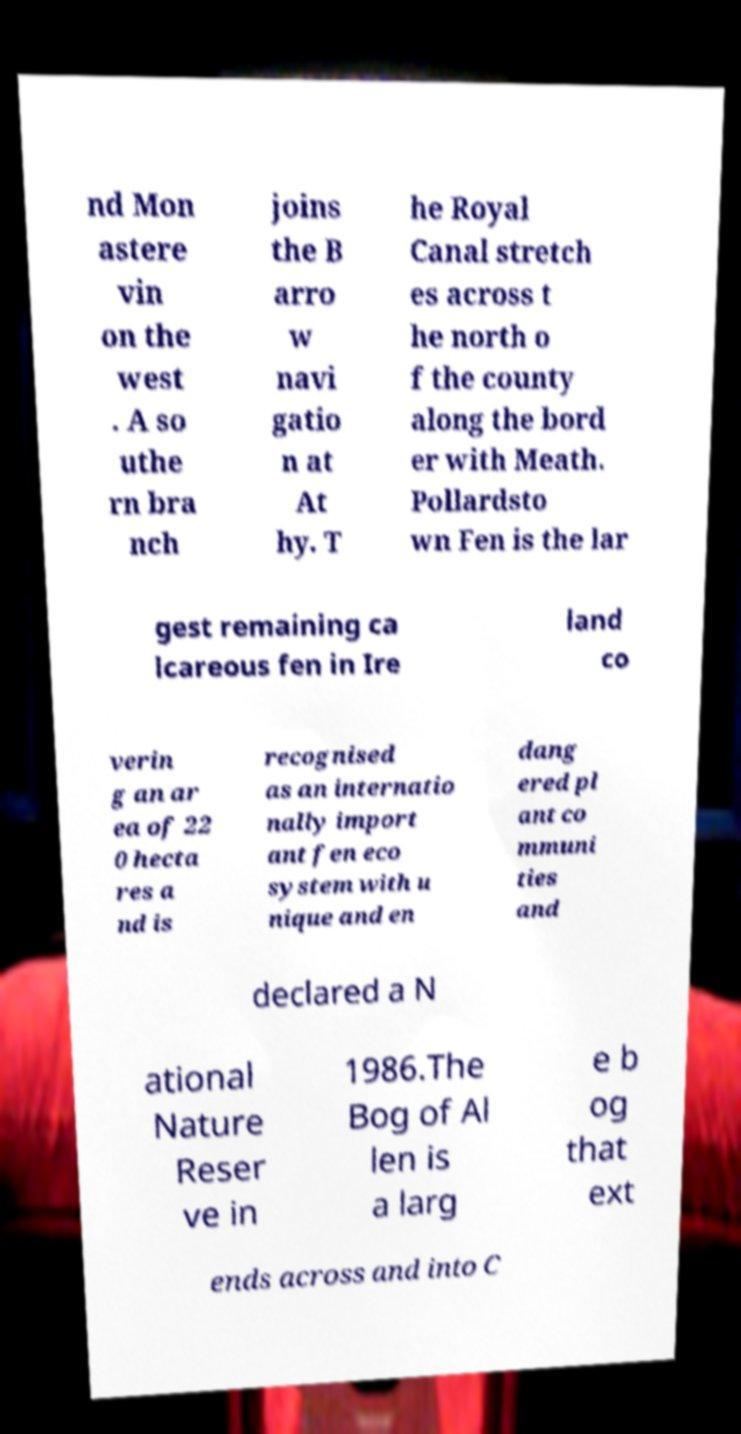Please identify and transcribe the text found in this image. nd Mon astere vin on the west . A so uthe rn bra nch joins the B arro w navi gatio n at At hy. T he Royal Canal stretch es across t he north o f the county along the bord er with Meath. Pollardsto wn Fen is the lar gest remaining ca lcareous fen in Ire land co verin g an ar ea of 22 0 hecta res a nd is recognised as an internatio nally import ant fen eco system with u nique and en dang ered pl ant co mmuni ties and declared a N ational Nature Reser ve in 1986.The Bog of Al len is a larg e b og that ext ends across and into C 